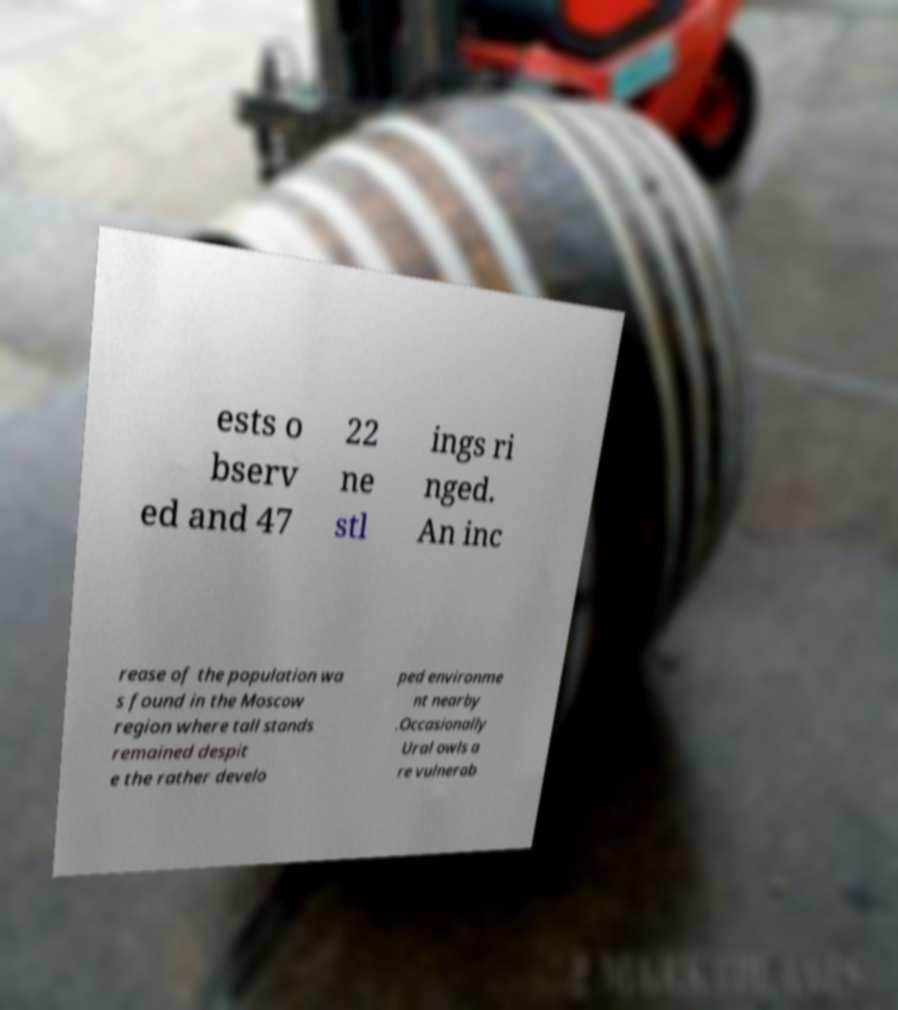I need the written content from this picture converted into text. Can you do that? ests o bserv ed and 47 22 ne stl ings ri nged. An inc rease of the population wa s found in the Moscow region where tall stands remained despit e the rather develo ped environme nt nearby .Occasionally Ural owls a re vulnerab 